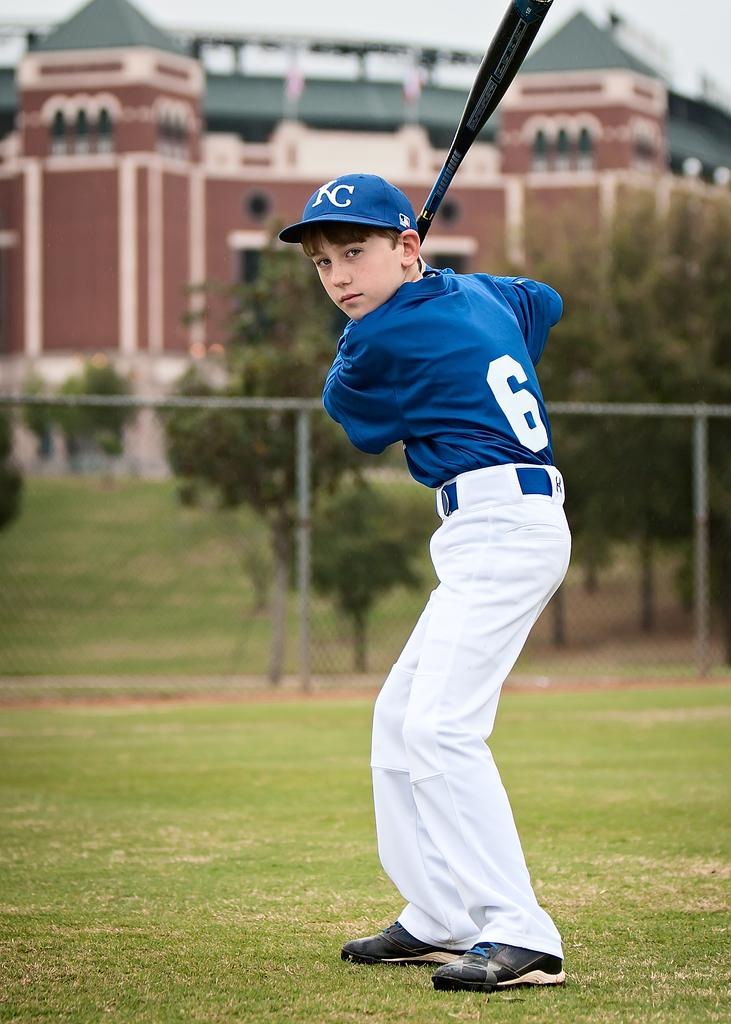<image>
Render a clear and concise summary of the photo. Youth baseball player holding a bat and has KC on his ball cap in white lettering 